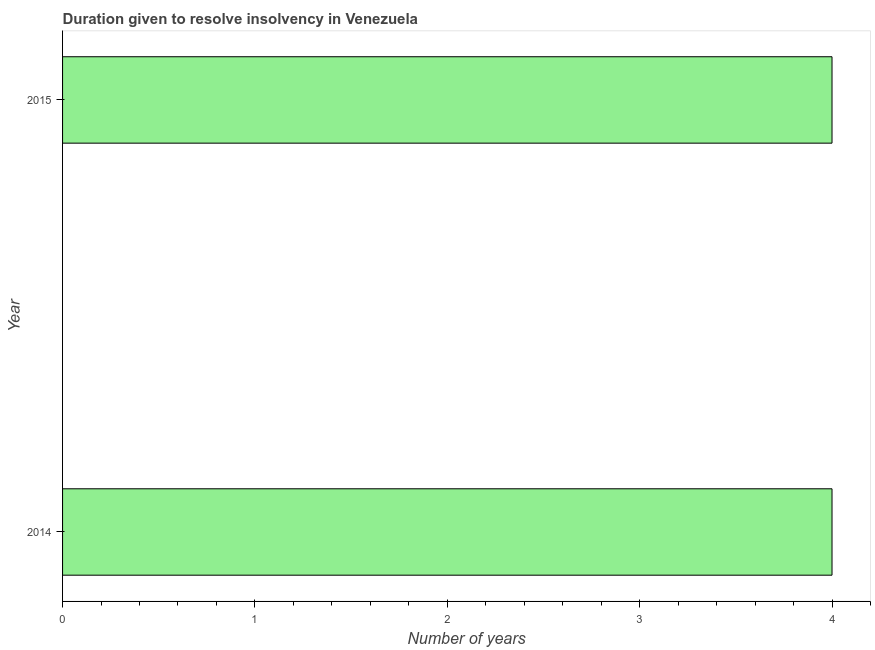Does the graph contain any zero values?
Provide a succinct answer. No. Does the graph contain grids?
Make the answer very short. No. What is the title of the graph?
Give a very brief answer. Duration given to resolve insolvency in Venezuela. What is the label or title of the X-axis?
Your answer should be compact. Number of years. What is the label or title of the Y-axis?
Offer a very short reply. Year. What is the number of years to resolve insolvency in 2015?
Your answer should be compact. 4. Across all years, what is the minimum number of years to resolve insolvency?
Offer a very short reply. 4. What is the sum of the number of years to resolve insolvency?
Provide a succinct answer. 8. What is the average number of years to resolve insolvency per year?
Keep it short and to the point. 4. In how many years, is the number of years to resolve insolvency greater than 0.6 ?
Ensure brevity in your answer.  2. Do a majority of the years between 2015 and 2014 (inclusive) have number of years to resolve insolvency greater than 1.6 ?
Offer a terse response. No. What is the ratio of the number of years to resolve insolvency in 2014 to that in 2015?
Provide a short and direct response. 1. Are all the bars in the graph horizontal?
Give a very brief answer. Yes. What is the difference between two consecutive major ticks on the X-axis?
Your answer should be very brief. 1. What is the Number of years in 2015?
Ensure brevity in your answer.  4. What is the ratio of the Number of years in 2014 to that in 2015?
Give a very brief answer. 1. 